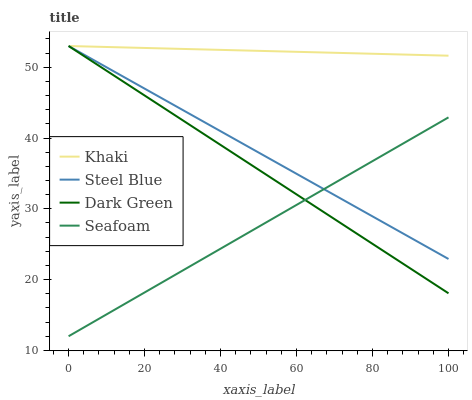Does Steel Blue have the minimum area under the curve?
Answer yes or no. No. Does Steel Blue have the maximum area under the curve?
Answer yes or no. No. Is Steel Blue the smoothest?
Answer yes or no. No. Is Steel Blue the roughest?
Answer yes or no. No. Does Steel Blue have the lowest value?
Answer yes or no. No. Does Seafoam have the highest value?
Answer yes or no. No. Is Seafoam less than Khaki?
Answer yes or no. Yes. Is Khaki greater than Seafoam?
Answer yes or no. Yes. Does Seafoam intersect Khaki?
Answer yes or no. No. 